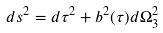Convert formula to latex. <formula><loc_0><loc_0><loc_500><loc_500>d s ^ { 2 } = d \tau ^ { 2 } + b ^ { 2 } ( \tau ) d \Omega _ { 3 } ^ { 2 }</formula> 